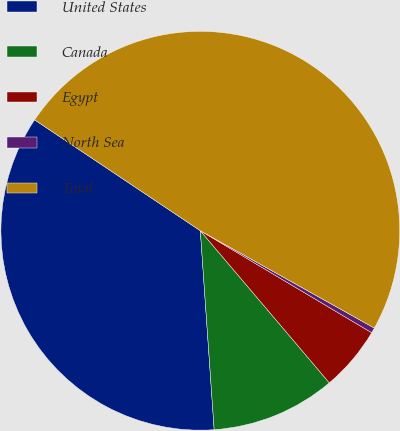<chart> <loc_0><loc_0><loc_500><loc_500><pie_chart><fcel>United States<fcel>Canada<fcel>Egypt<fcel>North Sea<fcel>Total<nl><fcel>35.49%<fcel>10.09%<fcel>5.26%<fcel>0.43%<fcel>48.73%<nl></chart> 